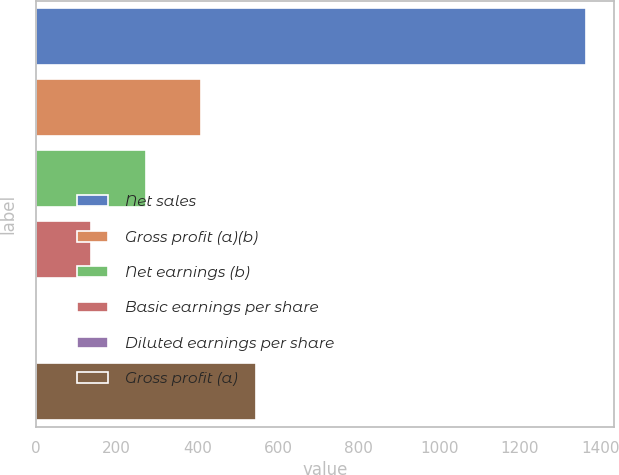Convert chart to OTSL. <chart><loc_0><loc_0><loc_500><loc_500><bar_chart><fcel>Net sales<fcel>Gross profit (a)(b)<fcel>Net earnings (b)<fcel>Basic earnings per share<fcel>Diluted earnings per share<fcel>Gross profit (a)<nl><fcel>1364.9<fcel>409.77<fcel>273.32<fcel>136.87<fcel>0.42<fcel>546.22<nl></chart> 